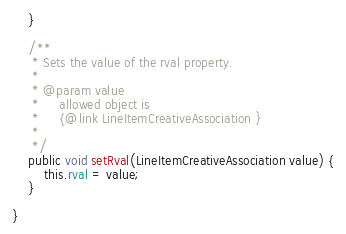Convert code to text. <code><loc_0><loc_0><loc_500><loc_500><_Java_>    }

    /**
     * Sets the value of the rval property.
     * 
     * @param value
     *     allowed object is
     *     {@link LineItemCreativeAssociation }
     *     
     */
    public void setRval(LineItemCreativeAssociation value) {
        this.rval = value;
    }

}
</code> 